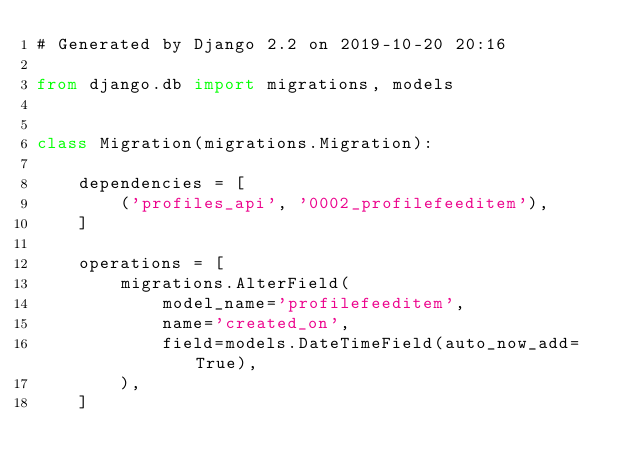Convert code to text. <code><loc_0><loc_0><loc_500><loc_500><_Python_># Generated by Django 2.2 on 2019-10-20 20:16

from django.db import migrations, models


class Migration(migrations.Migration):

    dependencies = [
        ('profiles_api', '0002_profilefeeditem'),
    ]

    operations = [
        migrations.AlterField(
            model_name='profilefeeditem',
            name='created_on',
            field=models.DateTimeField(auto_now_add=True),
        ),
    ]
</code> 